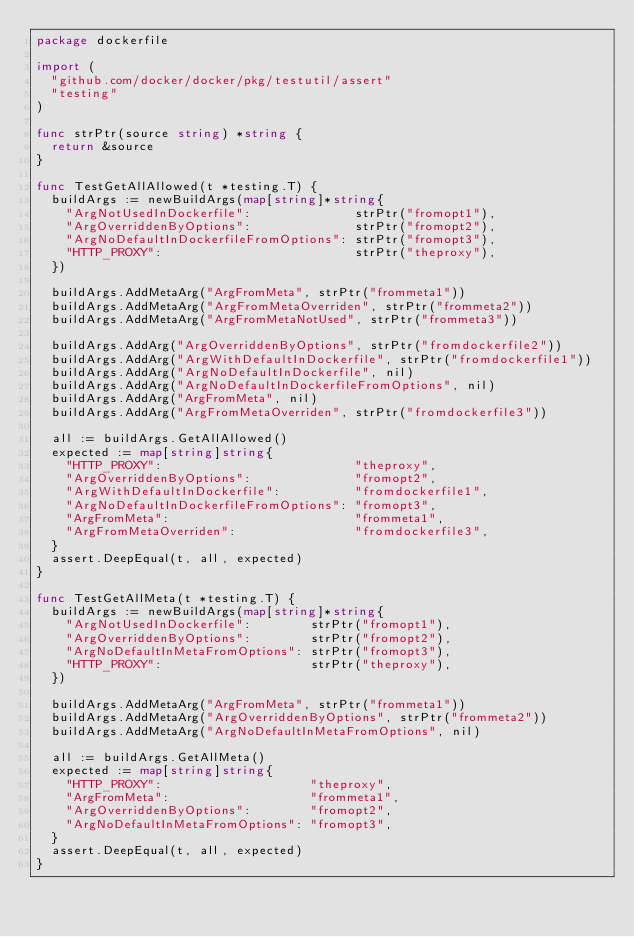<code> <loc_0><loc_0><loc_500><loc_500><_Go_>package dockerfile

import (
	"github.com/docker/docker/pkg/testutil/assert"
	"testing"
)

func strPtr(source string) *string {
	return &source
}

func TestGetAllAllowed(t *testing.T) {
	buildArgs := newBuildArgs(map[string]*string{
		"ArgNotUsedInDockerfile":              strPtr("fromopt1"),
		"ArgOverriddenByOptions":              strPtr("fromopt2"),
		"ArgNoDefaultInDockerfileFromOptions": strPtr("fromopt3"),
		"HTTP_PROXY":                          strPtr("theproxy"),
	})

	buildArgs.AddMetaArg("ArgFromMeta", strPtr("frommeta1"))
	buildArgs.AddMetaArg("ArgFromMetaOverriden", strPtr("frommeta2"))
	buildArgs.AddMetaArg("ArgFromMetaNotUsed", strPtr("frommeta3"))

	buildArgs.AddArg("ArgOverriddenByOptions", strPtr("fromdockerfile2"))
	buildArgs.AddArg("ArgWithDefaultInDockerfile", strPtr("fromdockerfile1"))
	buildArgs.AddArg("ArgNoDefaultInDockerfile", nil)
	buildArgs.AddArg("ArgNoDefaultInDockerfileFromOptions", nil)
	buildArgs.AddArg("ArgFromMeta", nil)
	buildArgs.AddArg("ArgFromMetaOverriden", strPtr("fromdockerfile3"))

	all := buildArgs.GetAllAllowed()
	expected := map[string]string{
		"HTTP_PROXY":                          "theproxy",
		"ArgOverriddenByOptions":              "fromopt2",
		"ArgWithDefaultInDockerfile":          "fromdockerfile1",
		"ArgNoDefaultInDockerfileFromOptions": "fromopt3",
		"ArgFromMeta":                         "frommeta1",
		"ArgFromMetaOverriden":                "fromdockerfile3",
	}
	assert.DeepEqual(t, all, expected)
}

func TestGetAllMeta(t *testing.T) {
	buildArgs := newBuildArgs(map[string]*string{
		"ArgNotUsedInDockerfile":        strPtr("fromopt1"),
		"ArgOverriddenByOptions":        strPtr("fromopt2"),
		"ArgNoDefaultInMetaFromOptions": strPtr("fromopt3"),
		"HTTP_PROXY":                    strPtr("theproxy"),
	})

	buildArgs.AddMetaArg("ArgFromMeta", strPtr("frommeta1"))
	buildArgs.AddMetaArg("ArgOverriddenByOptions", strPtr("frommeta2"))
	buildArgs.AddMetaArg("ArgNoDefaultInMetaFromOptions", nil)

	all := buildArgs.GetAllMeta()
	expected := map[string]string{
		"HTTP_PROXY":                    "theproxy",
		"ArgFromMeta":                   "frommeta1",
		"ArgOverriddenByOptions":        "fromopt2",
		"ArgNoDefaultInMetaFromOptions": "fromopt3",
	}
	assert.DeepEqual(t, all, expected)
}
</code> 